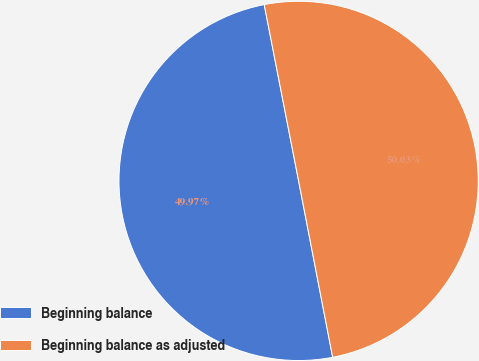Convert chart to OTSL. <chart><loc_0><loc_0><loc_500><loc_500><pie_chart><fcel>Beginning balance<fcel>Beginning balance as adjusted<nl><fcel>49.97%<fcel>50.03%<nl></chart> 